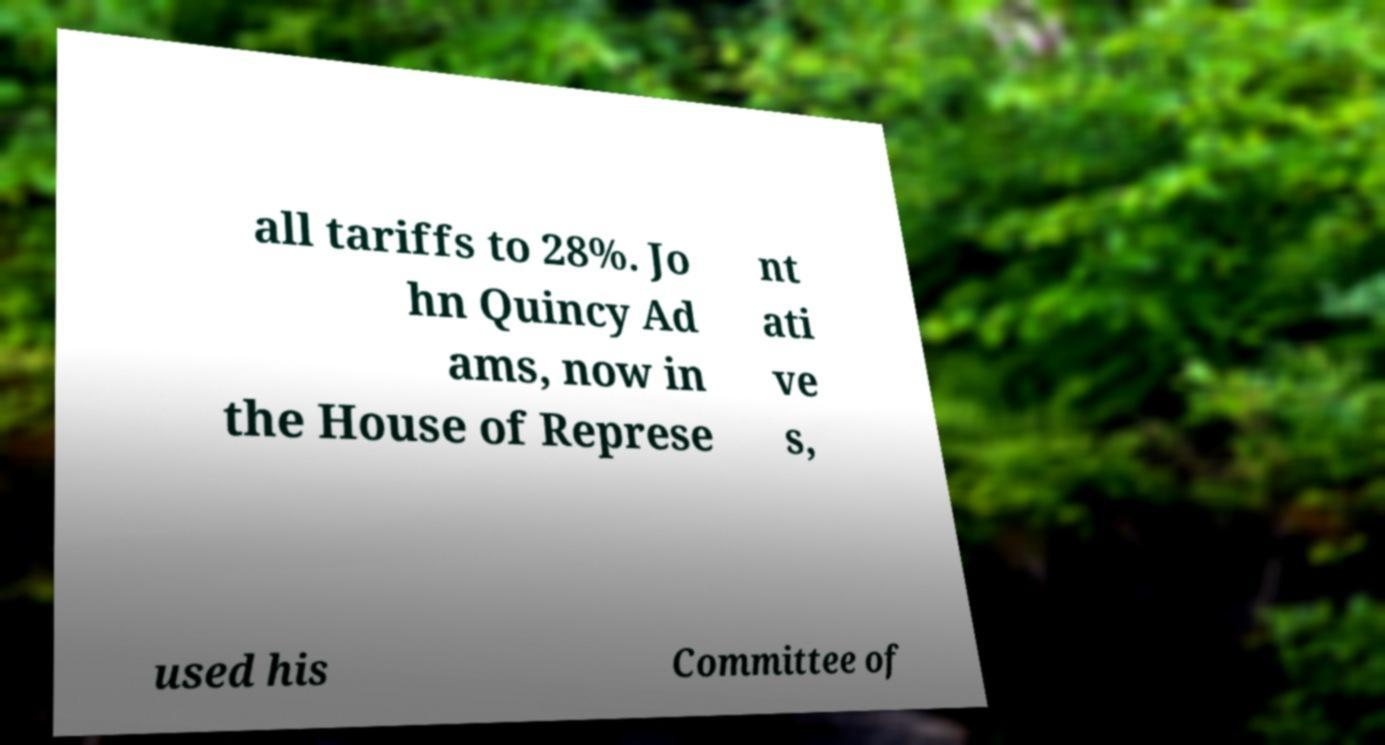Could you extract and type out the text from this image? all tariffs to 28%. Jo hn Quincy Ad ams, now in the House of Represe nt ati ve s, used his Committee of 